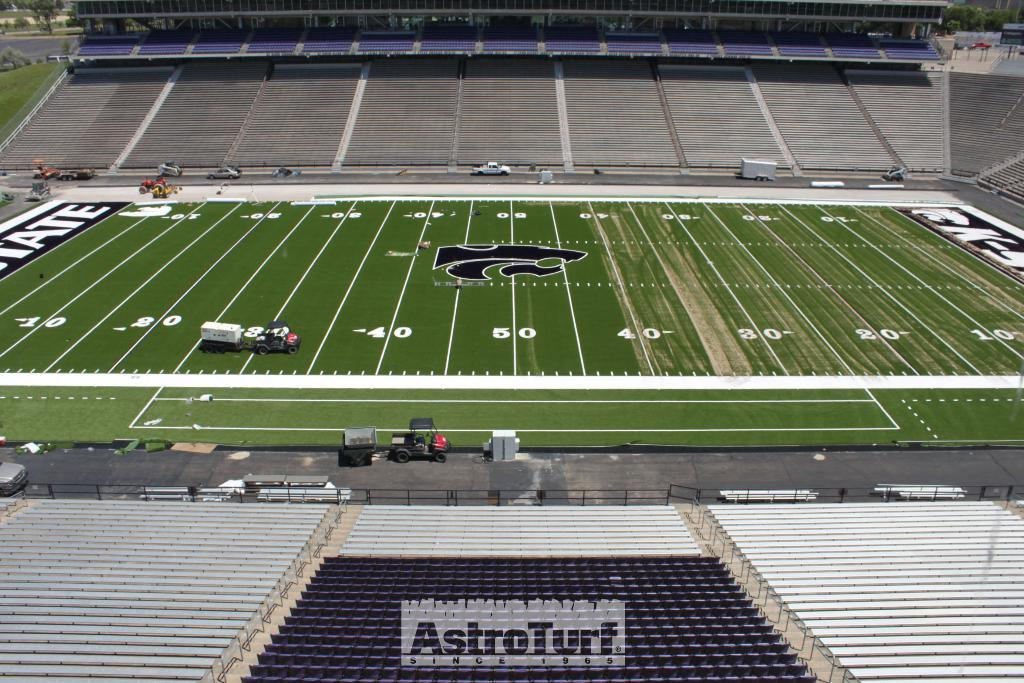<image>
Summarize the visual content of the image. An empty football stadium has the words AstroTurf over one seating section. 